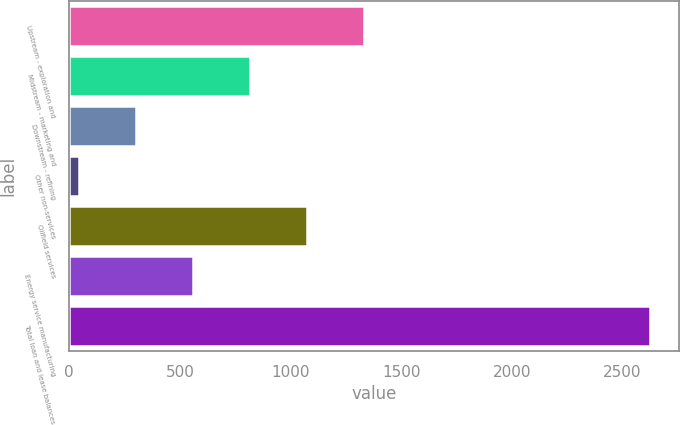<chart> <loc_0><loc_0><loc_500><loc_500><bar_chart><fcel>Upstream - exploration and<fcel>Midstream - marketing and<fcel>Downstream - refining<fcel>Other non-services<fcel>Oilfield services<fcel>Energy service manufacturing<fcel>Total loan and lease balances<nl><fcel>1333<fcel>817.4<fcel>301.8<fcel>44<fcel>1075.2<fcel>559.6<fcel>2622<nl></chart> 